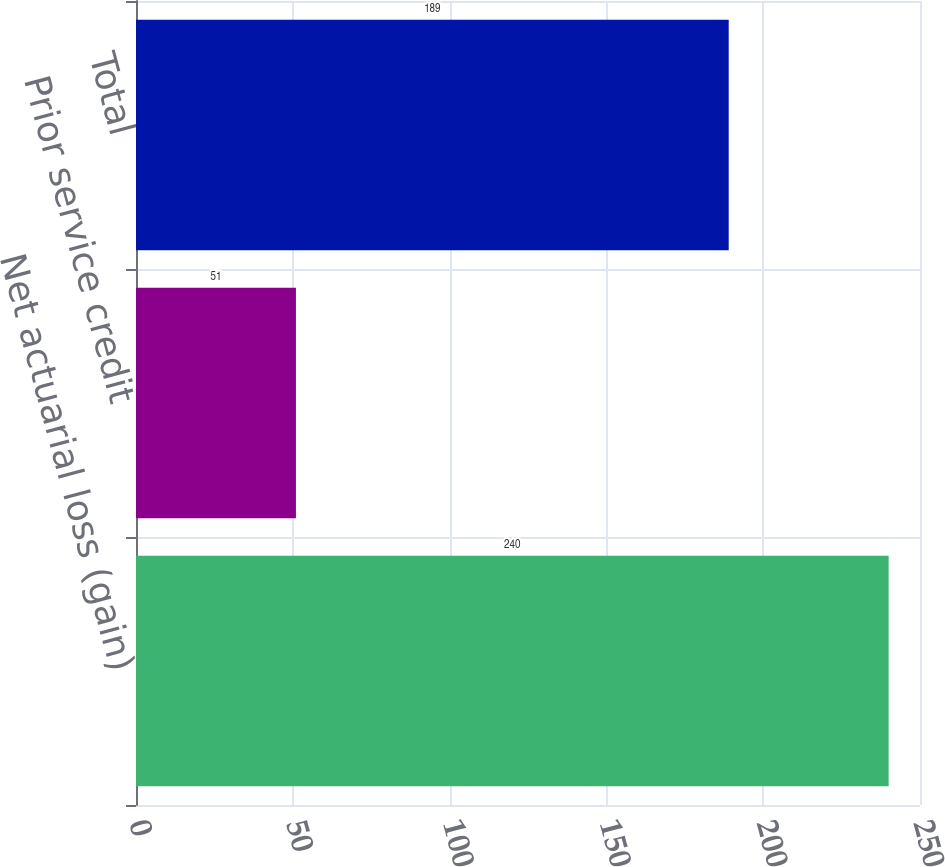<chart> <loc_0><loc_0><loc_500><loc_500><bar_chart><fcel>Net actuarial loss (gain)<fcel>Prior service credit<fcel>Total<nl><fcel>240<fcel>51<fcel>189<nl></chart> 